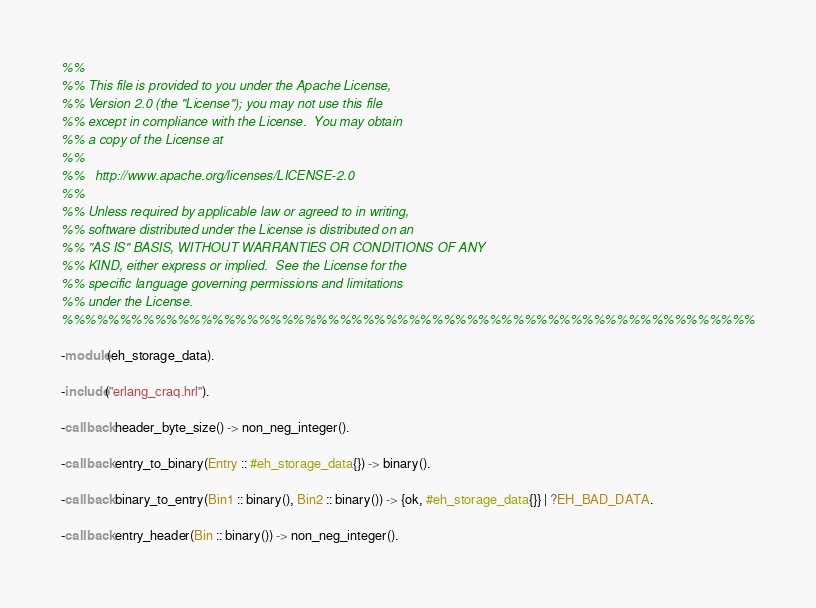<code> <loc_0><loc_0><loc_500><loc_500><_Erlang_>%%
%% This file is provided to you under the Apache License,
%% Version 2.0 (the "License"); you may not use this file
%% except in compliance with the License.  You may obtain
%% a copy of the License at
%%
%%   http://www.apache.org/licenses/LICENSE-2.0
%%
%% Unless required by applicable law or agreed to in writing,
%% software distributed under the License is distributed on an
%% "AS IS" BASIS, WITHOUT WARRANTIES OR CONDITIONS OF ANY
%% KIND, either express or implied.  See the License for the
%% specific language governing permissions and limitations
%% under the License.
%%%%%%%%%%%%%%%%%%%%%%%%%%%%%%%%%%%%%%%%%%%%%%%%%%%%%%%%%%%%

-module(eh_storage_data).

-include("erlang_craq.hrl").

-callback header_byte_size() -> non_neg_integer().

-callback entry_to_binary(Entry :: #eh_storage_data{}) -> binary().

-callback binary_to_entry(Bin1 :: binary(), Bin2 :: binary()) -> {ok, #eh_storage_data{}} | ?EH_BAD_DATA.

-callback entry_header(Bin :: binary()) -> non_neg_integer().
</code> 